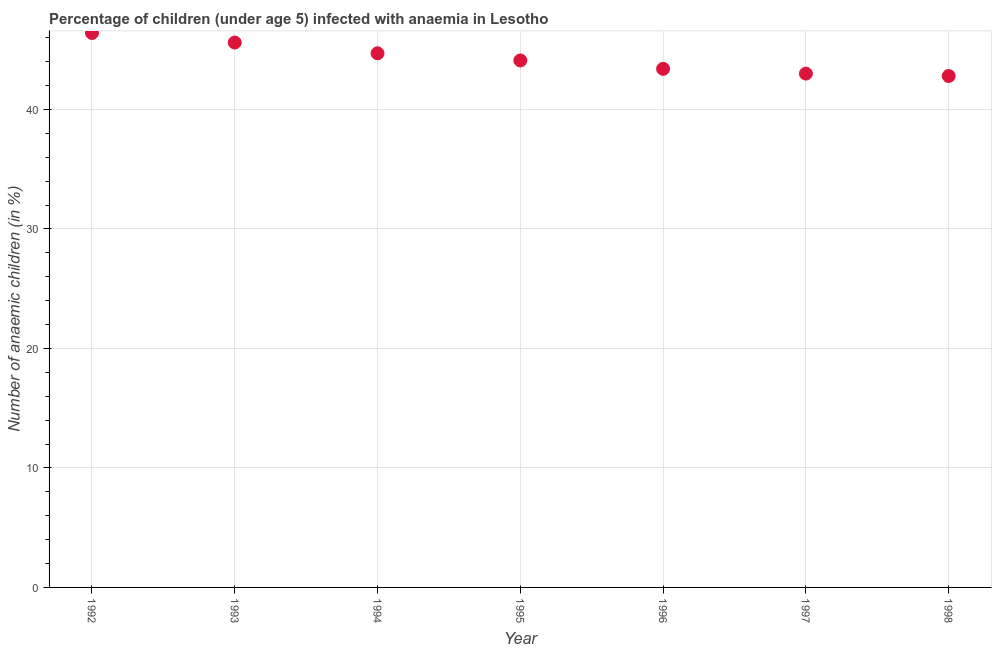Across all years, what is the maximum number of anaemic children?
Ensure brevity in your answer.  46.4. Across all years, what is the minimum number of anaemic children?
Provide a succinct answer. 42.8. In which year was the number of anaemic children maximum?
Make the answer very short. 1992. What is the sum of the number of anaemic children?
Ensure brevity in your answer.  310. What is the difference between the number of anaemic children in 1995 and 1997?
Provide a short and direct response. 1.1. What is the average number of anaemic children per year?
Offer a very short reply. 44.29. What is the median number of anaemic children?
Make the answer very short. 44.1. What is the ratio of the number of anaemic children in 1997 to that in 1998?
Provide a succinct answer. 1. Is the number of anaemic children in 1993 less than that in 1994?
Offer a very short reply. No. Is the difference between the number of anaemic children in 1995 and 1996 greater than the difference between any two years?
Ensure brevity in your answer.  No. What is the difference between the highest and the second highest number of anaemic children?
Provide a short and direct response. 0.8. Is the sum of the number of anaemic children in 1992 and 1998 greater than the maximum number of anaemic children across all years?
Your response must be concise. Yes. What is the difference between the highest and the lowest number of anaemic children?
Your answer should be very brief. 3.6. Does the number of anaemic children monotonically increase over the years?
Provide a short and direct response. No. How many dotlines are there?
Your response must be concise. 1. How many years are there in the graph?
Ensure brevity in your answer.  7. Are the values on the major ticks of Y-axis written in scientific E-notation?
Your response must be concise. No. Does the graph contain any zero values?
Your answer should be compact. No. Does the graph contain grids?
Make the answer very short. Yes. What is the title of the graph?
Keep it short and to the point. Percentage of children (under age 5) infected with anaemia in Lesotho. What is the label or title of the Y-axis?
Your answer should be compact. Number of anaemic children (in %). What is the Number of anaemic children (in %) in 1992?
Ensure brevity in your answer.  46.4. What is the Number of anaemic children (in %) in 1993?
Offer a very short reply. 45.6. What is the Number of anaemic children (in %) in 1994?
Provide a succinct answer. 44.7. What is the Number of anaemic children (in %) in 1995?
Keep it short and to the point. 44.1. What is the Number of anaemic children (in %) in 1996?
Give a very brief answer. 43.4. What is the Number of anaemic children (in %) in 1997?
Keep it short and to the point. 43. What is the Number of anaemic children (in %) in 1998?
Your answer should be compact. 42.8. What is the difference between the Number of anaemic children (in %) in 1992 and 1993?
Keep it short and to the point. 0.8. What is the difference between the Number of anaemic children (in %) in 1992 and 1997?
Make the answer very short. 3.4. What is the difference between the Number of anaemic children (in %) in 1992 and 1998?
Provide a short and direct response. 3.6. What is the difference between the Number of anaemic children (in %) in 1993 and 1996?
Ensure brevity in your answer.  2.2. What is the difference between the Number of anaemic children (in %) in 1993 and 1997?
Offer a terse response. 2.6. What is the difference between the Number of anaemic children (in %) in 1993 and 1998?
Offer a very short reply. 2.8. What is the difference between the Number of anaemic children (in %) in 1994 and 1996?
Your response must be concise. 1.3. What is the difference between the Number of anaemic children (in %) in 1995 and 1996?
Provide a succinct answer. 0.7. What is the difference between the Number of anaemic children (in %) in 1995 and 1998?
Provide a succinct answer. 1.3. What is the difference between the Number of anaemic children (in %) in 1996 and 1998?
Provide a short and direct response. 0.6. What is the difference between the Number of anaemic children (in %) in 1997 and 1998?
Provide a short and direct response. 0.2. What is the ratio of the Number of anaemic children (in %) in 1992 to that in 1994?
Your answer should be compact. 1.04. What is the ratio of the Number of anaemic children (in %) in 1992 to that in 1995?
Provide a succinct answer. 1.05. What is the ratio of the Number of anaemic children (in %) in 1992 to that in 1996?
Your response must be concise. 1.07. What is the ratio of the Number of anaemic children (in %) in 1992 to that in 1997?
Your response must be concise. 1.08. What is the ratio of the Number of anaemic children (in %) in 1992 to that in 1998?
Ensure brevity in your answer.  1.08. What is the ratio of the Number of anaemic children (in %) in 1993 to that in 1994?
Offer a terse response. 1.02. What is the ratio of the Number of anaemic children (in %) in 1993 to that in 1995?
Keep it short and to the point. 1.03. What is the ratio of the Number of anaemic children (in %) in 1993 to that in 1996?
Keep it short and to the point. 1.05. What is the ratio of the Number of anaemic children (in %) in 1993 to that in 1997?
Give a very brief answer. 1.06. What is the ratio of the Number of anaemic children (in %) in 1993 to that in 1998?
Your answer should be compact. 1.06. What is the ratio of the Number of anaemic children (in %) in 1994 to that in 1998?
Ensure brevity in your answer.  1.04. What is the ratio of the Number of anaemic children (in %) in 1995 to that in 1996?
Your answer should be very brief. 1.02. What is the ratio of the Number of anaemic children (in %) in 1996 to that in 1997?
Provide a succinct answer. 1.01. 